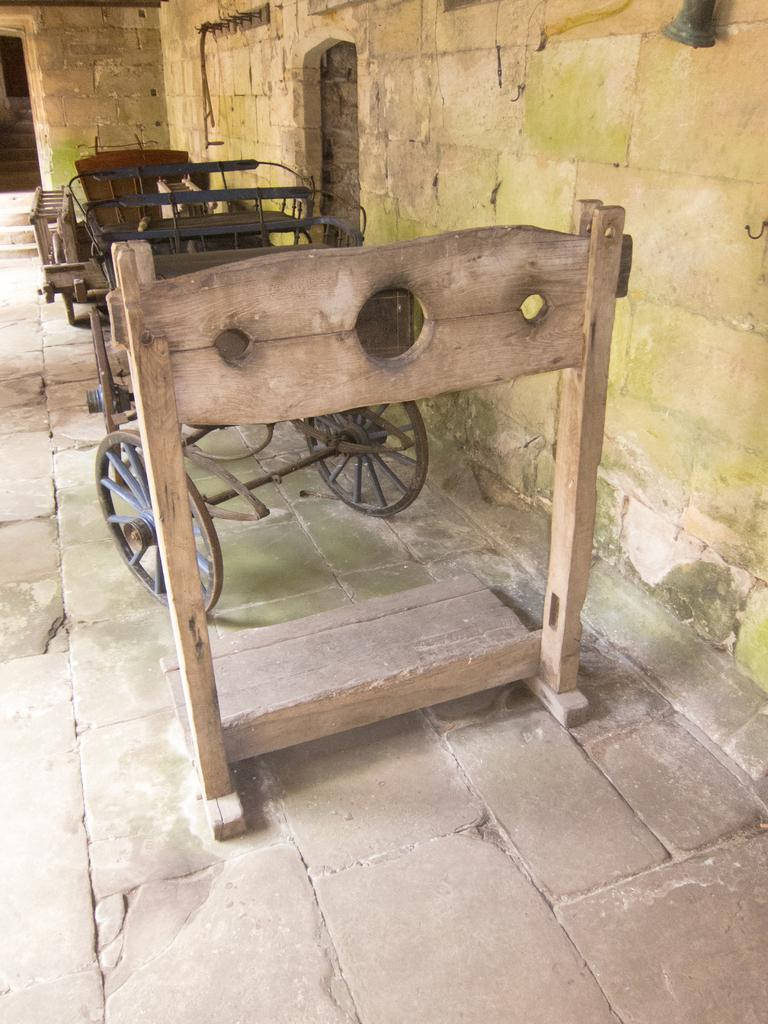What type of structure is present in the image? There is a wooden stand in the image. What other object can be seen in the image? There is an iron cart in the image. What material is used for the walls in the image? The place has stone walls. What is the floor made of in the image? The floor is made of stone. Where are the scissors located in the image? There are no scissors present in the image. What type of loss is depicted in the image? There is no loss depicted in the image; it features a wooden stand, an iron cart, stone walls, and a stone floor. 